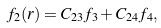<formula> <loc_0><loc_0><loc_500><loc_500>f _ { 2 } ( r ) = C _ { 2 3 } f _ { 3 } + C _ { 2 4 } f _ { 4 } ,</formula> 